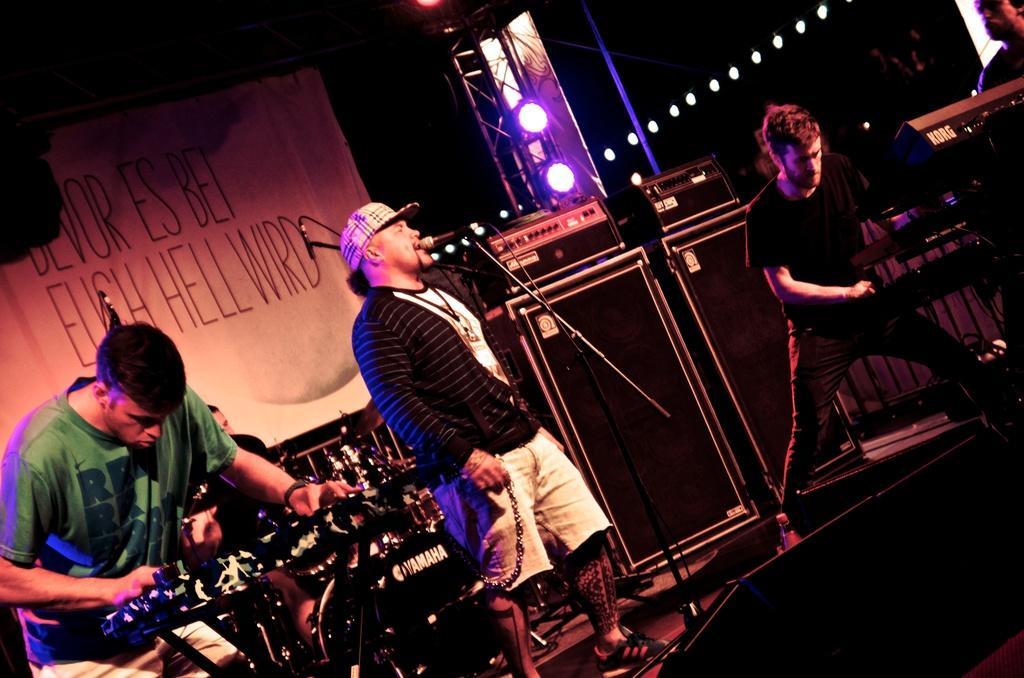Describe this image in one or two sentences. In this picture we can see some people playing musical instruments on stage where a man singing on mic, banner, speakers and in the background we can see the lights. 